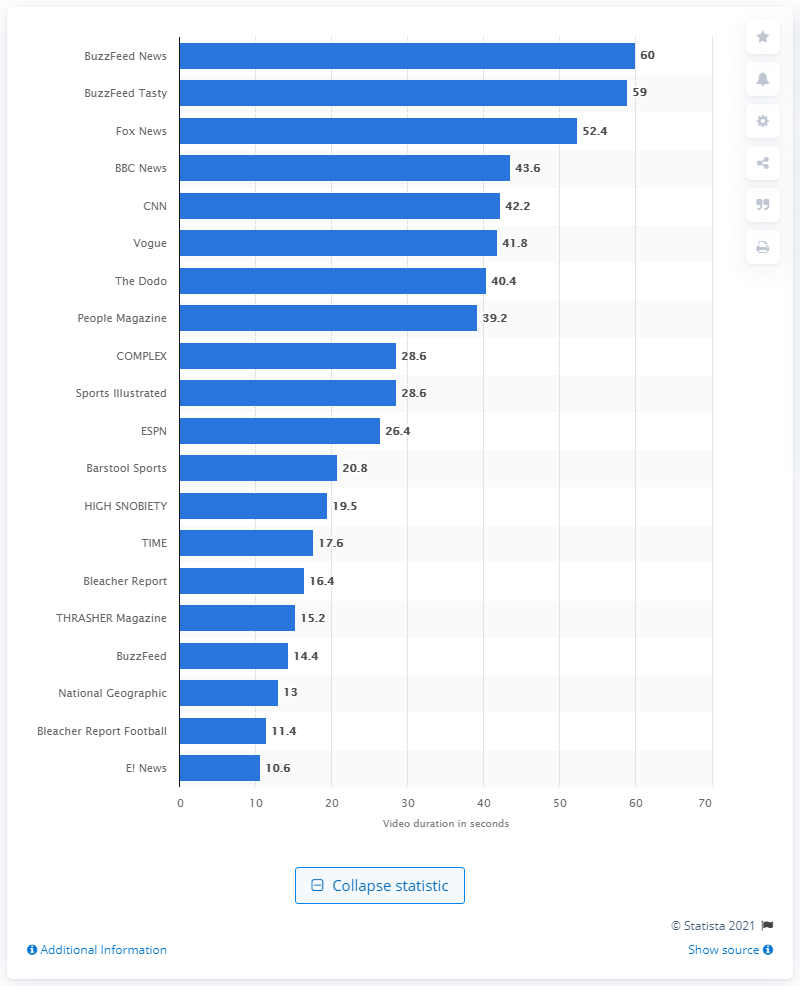Point out several critical features in this image. BuzzFeed Tasty has the second-longest average length of videos on Instagram. 